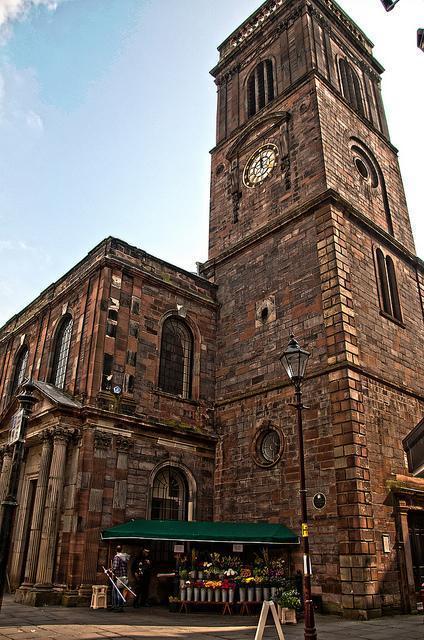How many bananas are pointed left?
Give a very brief answer. 0. 